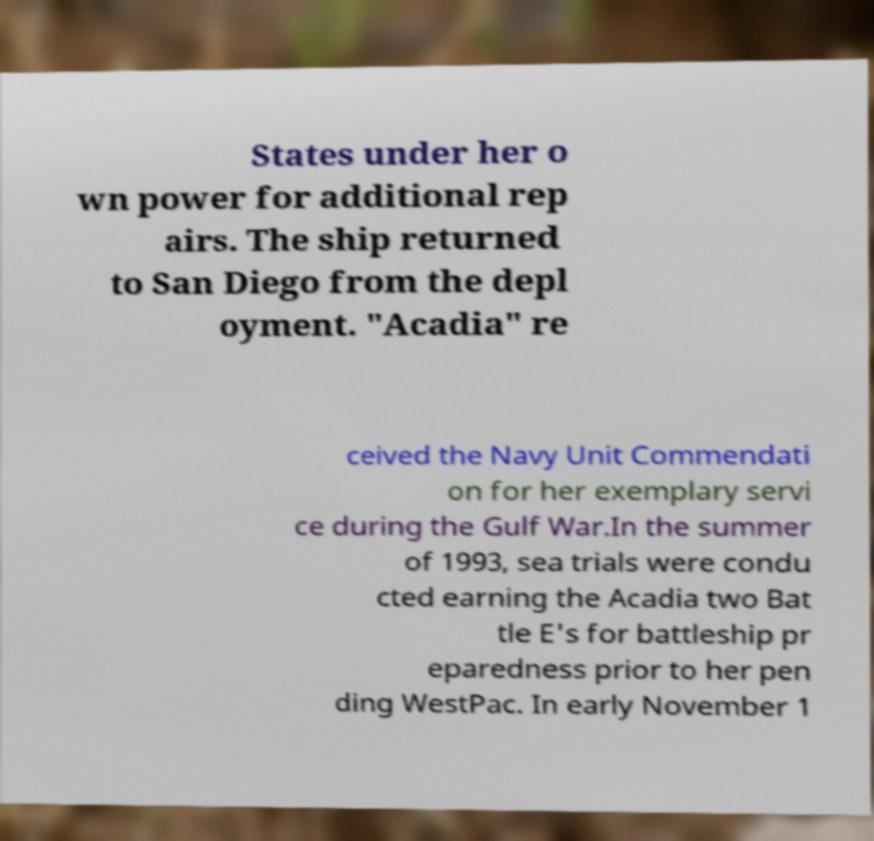Could you assist in decoding the text presented in this image and type it out clearly? States under her o wn power for additional rep airs. The ship returned to San Diego from the depl oyment. "Acadia" re ceived the Navy Unit Commendati on for her exemplary servi ce during the Gulf War.In the summer of 1993, sea trials were condu cted earning the Acadia two Bat tle E's for battleship pr eparedness prior to her pen ding WestPac. In early November 1 